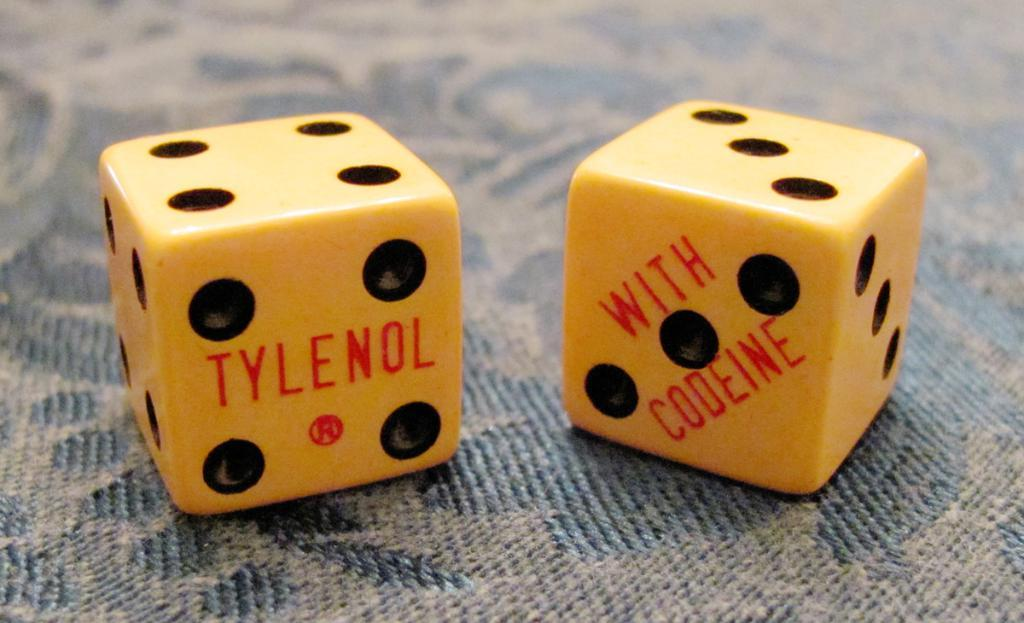What objects are in the image that have a yellow color? There are two yellow dice in the image. What is the dice placed on? The dice are on a cloth. What colors can be seen on the dice? There are red texts and black dots on the dice. How would you describe the background of the image? The background of the image is blurred. What type of glue is being used to hold the dice together in the image? There is no glue present in the image, and the dice are not being held together. Can you see any wilderness or natural landscapes in the image? No, there is no wilderness or natural landscapes visible in the image; it features two yellow dice on a cloth. 